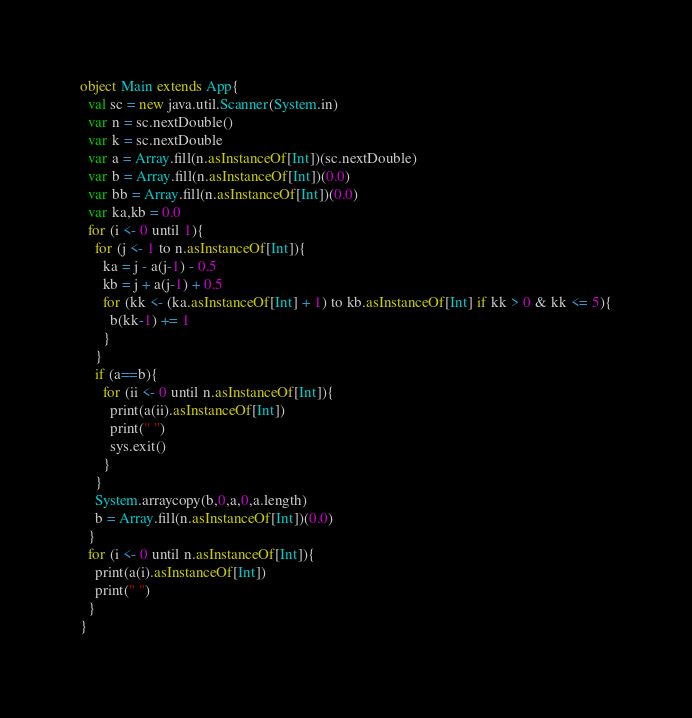Convert code to text. <code><loc_0><loc_0><loc_500><loc_500><_Scala_>object Main extends App{
  val sc = new java.util.Scanner(System.in)
  var n = sc.nextDouble()
  var k = sc.nextDouble
  var a = Array.fill(n.asInstanceOf[Int])(sc.nextDouble)
  var b = Array.fill(n.asInstanceOf[Int])(0.0)
  var bb = Array.fill(n.asInstanceOf[Int])(0.0)
  var ka,kb = 0.0
  for (i <- 0 until 1){
    for (j <- 1 to n.asInstanceOf[Int]){
      ka = j - a(j-1) - 0.5
      kb = j + a(j-1) + 0.5
      for (kk <- (ka.asInstanceOf[Int] + 1) to kb.asInstanceOf[Int] if kk > 0 & kk <= 5){
        b(kk-1) += 1
      }
    }
    if (a==b){
      for (ii <- 0 until n.asInstanceOf[Int]){
        print(a(ii).asInstanceOf[Int])
        print(" ")
        sys.exit()
      }
    }
    System.arraycopy(b,0,a,0,a.length)
    b = Array.fill(n.asInstanceOf[Int])(0.0)
  }
  for (i <- 0 until n.asInstanceOf[Int]){
    print(a(i).asInstanceOf[Int])
    print(" ")
  }
}
</code> 